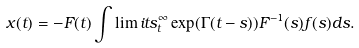<formula> <loc_0><loc_0><loc_500><loc_500>x ( t ) = - F ( t ) \int \lim i t s _ { t } ^ { \infty } \exp ( \Gamma ( t - s ) ) F ^ { - 1 } ( s ) f ( s ) d s .</formula> 